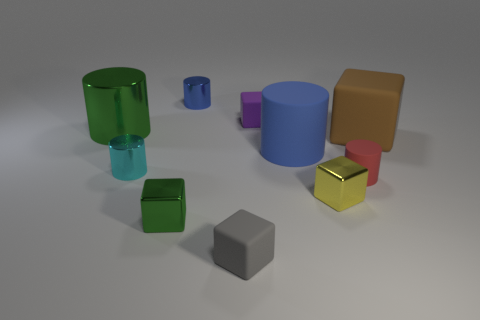How many purple matte objects are the same shape as the red object?
Offer a very short reply. 0. There is a tiny cube behind the tiny red object; what material is it?
Your response must be concise. Rubber. There is a tiny metal thing right of the large blue cylinder; does it have the same shape as the purple rubber thing?
Provide a succinct answer. Yes. Are there any shiny blocks of the same size as the gray object?
Your answer should be compact. Yes. Does the large green thing have the same shape as the blue thing to the left of the large matte cylinder?
Offer a terse response. Yes. What shape is the small thing that is the same color as the big metallic cylinder?
Offer a very short reply. Cube. Are there fewer large brown rubber things that are to the left of the small green metallic block than small brown cylinders?
Ensure brevity in your answer.  No. Is the shape of the tiny gray thing the same as the tiny green metallic thing?
Provide a short and direct response. Yes. There is a blue cylinder that is the same material as the tiny red thing; what is its size?
Ensure brevity in your answer.  Large. Are there fewer green metal cubes than big rubber things?
Your answer should be compact. Yes. 